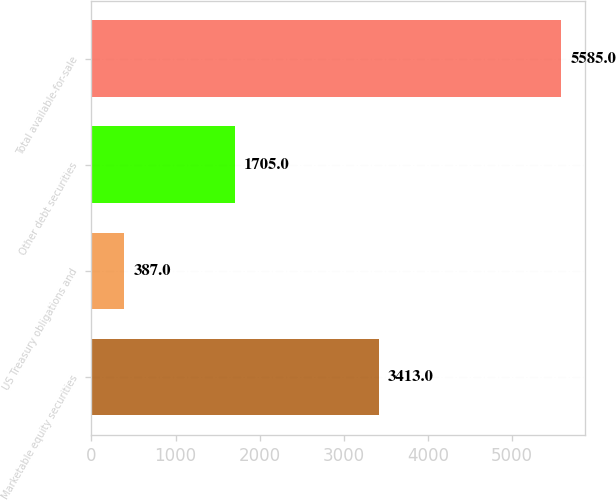Convert chart. <chart><loc_0><loc_0><loc_500><loc_500><bar_chart><fcel>Marketable equity securities<fcel>US Treasury obligations and<fcel>Other debt securities<fcel>Total available-for-sale<nl><fcel>3413<fcel>387<fcel>1705<fcel>5585<nl></chart> 